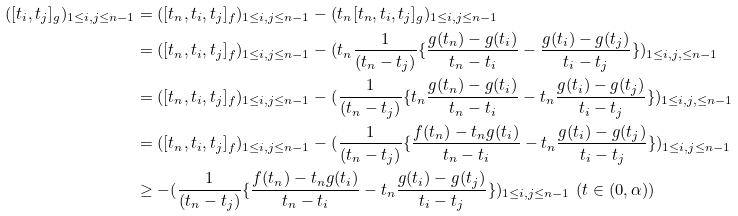Convert formula to latex. <formula><loc_0><loc_0><loc_500><loc_500>( [ t _ { i } , t _ { j } ] _ { g } ) _ { 1 \leq i , j \leq n - 1 } & = ( [ t _ { n } , t _ { i } , t _ { j } ] _ { f } ) _ { 1 \leq i , j \leq n - 1 } - ( t _ { n } [ t _ { n } , t _ { i } , t _ { j } ] _ { g } ) _ { 1 \leq i , j \leq n - 1 } \\ & = ( [ t _ { n } , t _ { i } , t _ { j } ] _ { f } ) _ { 1 \leq i , j \leq n - 1 } - ( t _ { n } \frac { 1 } { ( t _ { n } - t _ { j } ) } \{ \frac { g ( t _ { n } ) - g ( t _ { i } ) } { t _ { n } - t _ { i } } - \frac { g ( t _ { i } ) - g ( t _ { j } ) } { t _ { i } - t _ { j } } \} ) _ { 1 \leq i , j , \leq n - 1 } \\ & = ( [ t _ { n } , t _ { i } , t _ { j } ] _ { f } ) _ { 1 \leq i , j \leq n - 1 } - ( \frac { 1 } { ( t _ { n } - t _ { j } ) } \{ t _ { n } \frac { g ( t _ { n } ) - g ( t _ { i } ) } { t _ { n } - t _ { i } } - t _ { n } \frac { g ( t _ { i } ) - g ( t _ { j } ) } { t _ { i } - t _ { j } } \} ) _ { 1 \leq i , j , \leq n - 1 } \\ & = ( [ t _ { n } , t _ { i } , t _ { j } ] _ { f } ) _ { 1 \leq i , j \leq n - 1 } - ( \frac { 1 } { ( t _ { n } - t _ { j } ) } \{ \frac { f ( t _ { n } ) - t _ { n } g ( t _ { i } ) } { t _ { n } - t _ { i } } - t _ { n } \frac { g ( t _ { i } ) - g ( t _ { j } ) } { t _ { i } - t _ { j } } \} ) _ { 1 \leq i , j \leq n - 1 } \\ & \geq - ( \frac { 1 } { ( t _ { n } - t _ { j } ) } \{ \frac { f ( t _ { n } ) - t _ { n } g ( t _ { i } ) } { t _ { n } - t _ { i } } - t _ { n } \frac { g ( t _ { i } ) - g ( t _ { j } ) } { t _ { i } - t _ { j } } \} ) _ { 1 \leq i , j \leq n - 1 } \ ( t \in ( 0 , \alpha ) )</formula> 